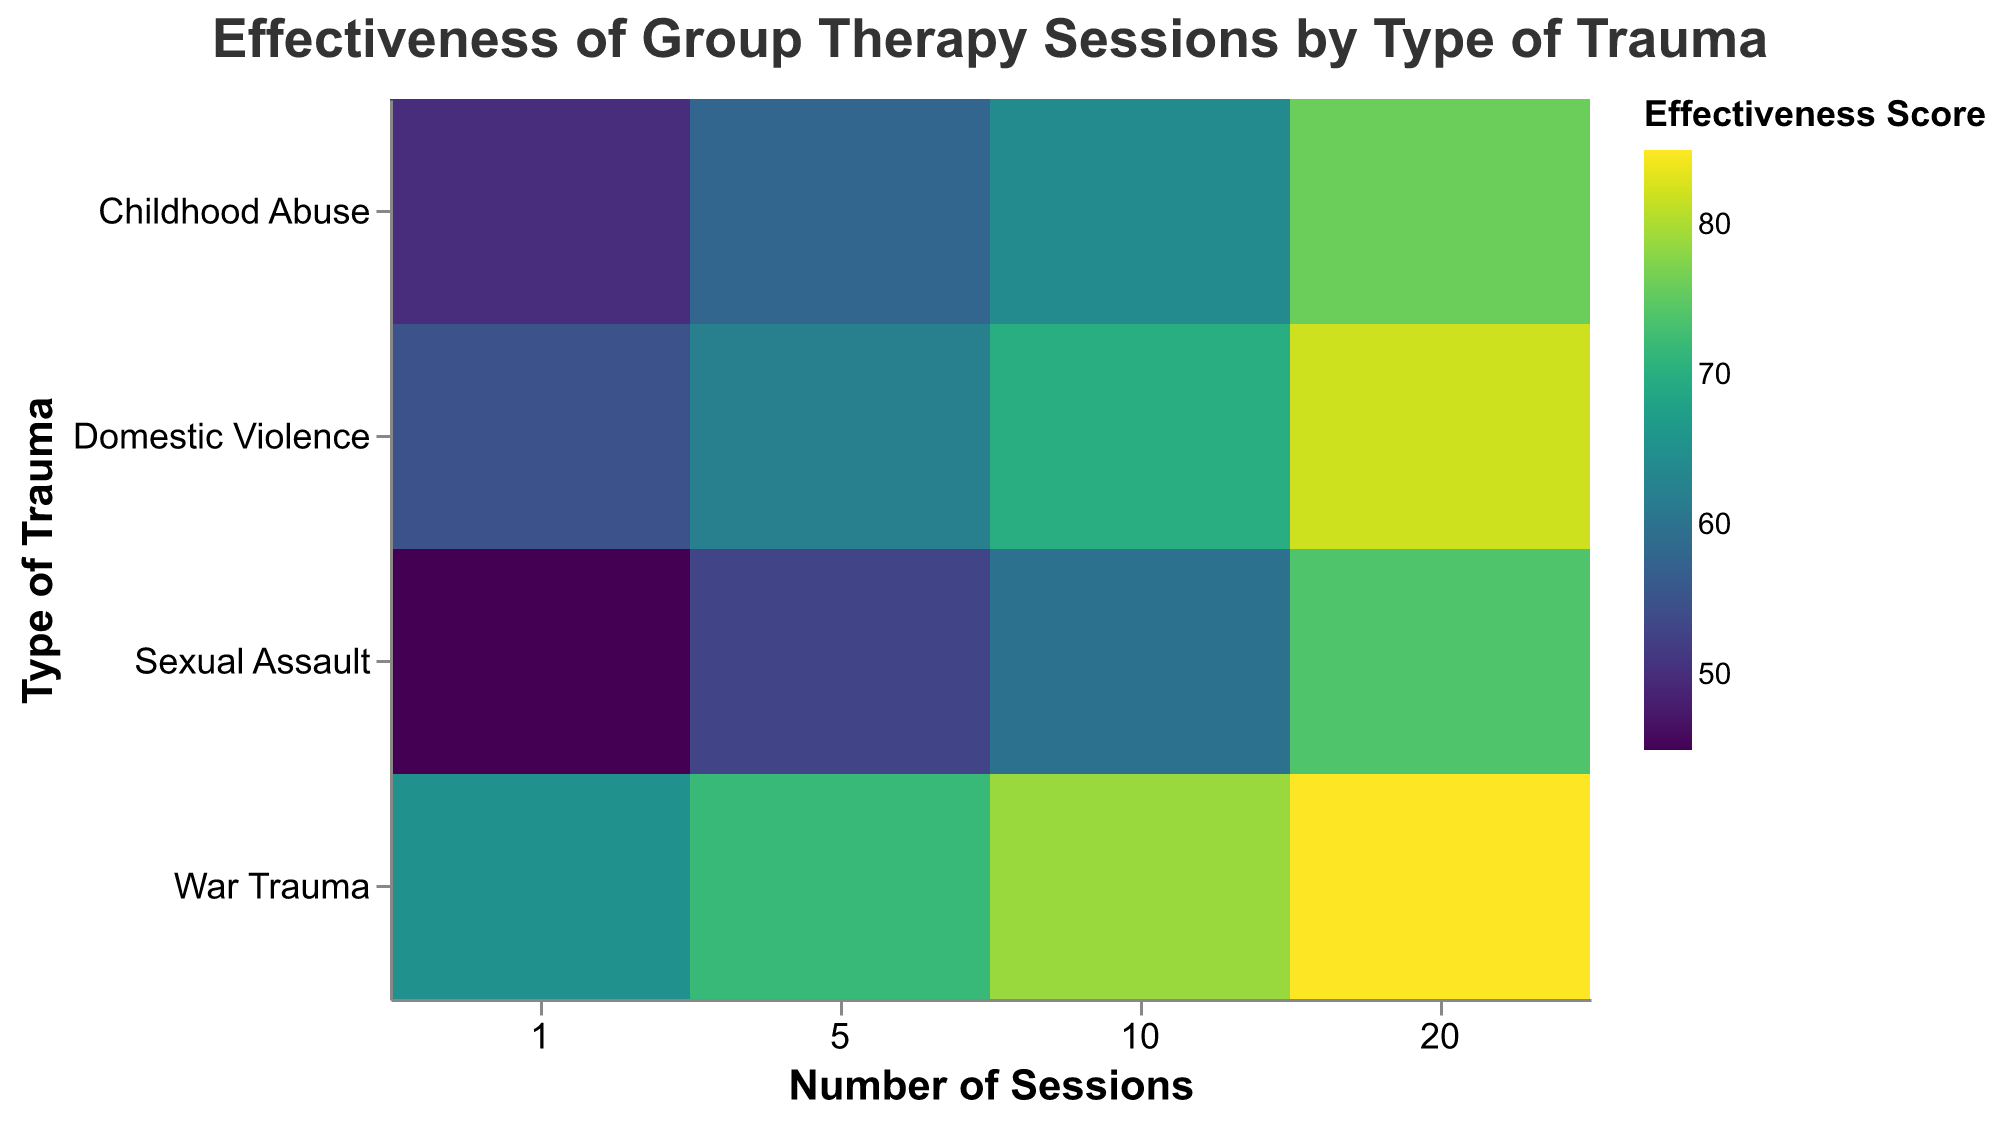What is the title of the heatmap? The title is placed at the top center of the heatmap and reads, "Effectiveness of Group Therapy Sessions by Type of Trauma."
Answer: Effectiveness of Group Therapy Sessions by Type of Trauma What is the effectiveness score for War Trauma with 10 sessions? Find the cell that corresponds to the intersection of "War Trauma" and "10" on the axes. The color of this cell maps to an effectiveness score of 79 based on the color legend.
Answer: 79 How does the effectiveness score change from 1 session to 20 sessions for Childhood Abuse? Locate the cells for Childhood Abuse at sessions 1 and 20. The scores are 50 and 76, respectively. The change is \(76 - 50\).
Answer: 26 Which type of trauma shows the highest effectiveness score with 5 sessions? By comparing the cells for 5 sessions across all trauma types, you can see that War Trauma has the highest score at 72.
Answer: War Trauma What is the average effectiveness score for 20 sessions across all trauma types? Sum up the effectiveness scores at 20 sessions: \(85 (War) + 76 (Childhood) + 82 (Domestic) + 74 (Sexual)\). The average is \(\frac{85 + 76 + 82 + 74}{4} = 79.25\).
Answer: 79.25 Which trauma type shows the least improvement in effectiveness from 1 to 20 sessions? Compute the difference for each trauma type from 1 to 20 sessions: War Trauma \(85 - 65 = 20\), Childhood Abuse \(76 - 50 = 26\), Domestic Violence \(82 - 55 = 27\), Sexual Assault \(74 - 45 = 29\). The smallest change is for War Trauma with a difference of 20.
Answer: War Trauma How does the effectiveness of group therapy for Domestic Violence after 10 sessions compare to Sexual Assault after 20 sessions? Compare the effectiveness scores: Domestic Violence after 10 sessions is 70, and Sexual Assault after 20 sessions is 74. Thus, the score for Sexual Assault after 20 sessions is higher.
Answer: Sexual Assault is higher What is the median effectiveness score for sexual assault across all sessions? The effectiveness scores for Sexual Assault are \[45, 53, 60, 74\]. The median is the average of the two middle numbers \((53 + 60)/2\).
Answer: 56.5 Which type of trauma benefits the most from increasing session count to 10? For each trauma type, calculate the increase in effectiveness from 1 to 10 sessions: War Trauma \(79 - 65 = 14\), Childhood Abuse \(64 - 50 = 14\), Domestic Violence \(70 - 55 = 15\), Sexual Assault \(60 - 45 = 15\). Domestic Violence and Sexual Assault both increase by 15.
Answer: Domestic Violence and Sexual Assault 